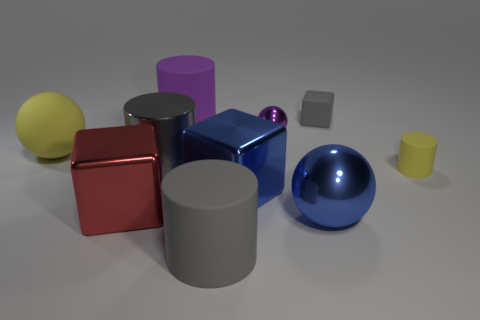What color is the other rubber object that is the same shape as the tiny purple object?
Your answer should be compact. Yellow. What number of large purple matte things are right of the cylinder that is behind the small block?
Keep it short and to the point. 0. What number of spheres are either small things or large yellow matte things?
Your answer should be compact. 2. Is there a ball?
Provide a short and direct response. Yes. The gray matte thing that is the same shape as the gray metallic thing is what size?
Provide a succinct answer. Large. There is a large gray object that is in front of the gray cylinder behind the tiny matte cylinder; what is its shape?
Ensure brevity in your answer.  Cylinder. How many red objects are tiny metallic cubes or tiny blocks?
Provide a short and direct response. 0. The rubber cube is what color?
Ensure brevity in your answer.  Gray. Do the gray cube and the purple matte thing have the same size?
Your answer should be very brief. No. Are there any other things that have the same shape as the red metal thing?
Your answer should be very brief. Yes. 